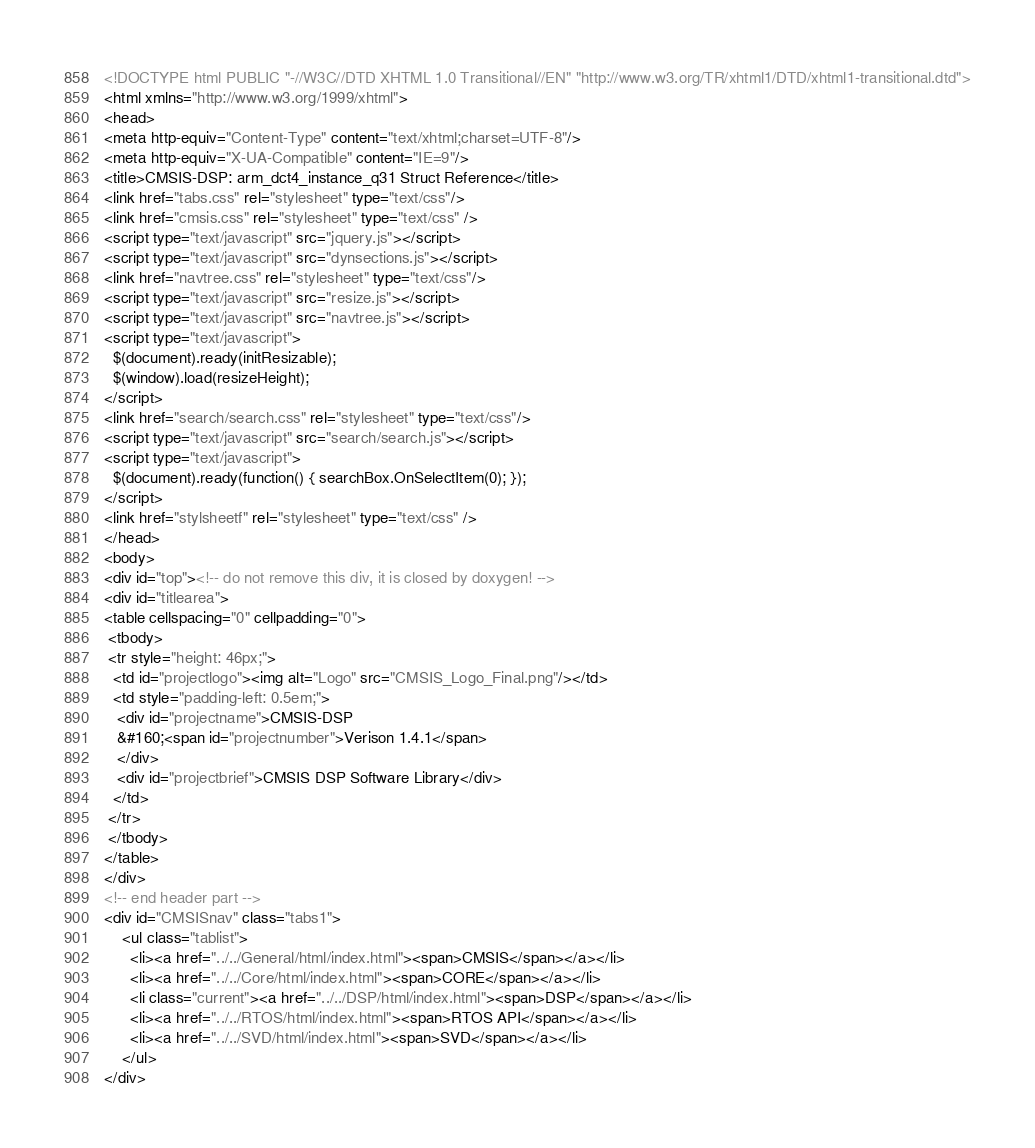Convert code to text. <code><loc_0><loc_0><loc_500><loc_500><_HTML_><!DOCTYPE html PUBLIC "-//W3C//DTD XHTML 1.0 Transitional//EN" "http://www.w3.org/TR/xhtml1/DTD/xhtml1-transitional.dtd">
<html xmlns="http://www.w3.org/1999/xhtml">
<head>
<meta http-equiv="Content-Type" content="text/xhtml;charset=UTF-8"/>
<meta http-equiv="X-UA-Compatible" content="IE=9"/>
<title>CMSIS-DSP: arm_dct4_instance_q31 Struct Reference</title>
<link href="tabs.css" rel="stylesheet" type="text/css"/>
<link href="cmsis.css" rel="stylesheet" type="text/css" />
<script type="text/javascript" src="jquery.js"></script>
<script type="text/javascript" src="dynsections.js"></script>
<link href="navtree.css" rel="stylesheet" type="text/css"/>
<script type="text/javascript" src="resize.js"></script>
<script type="text/javascript" src="navtree.js"></script>
<script type="text/javascript">
  $(document).ready(initResizable);
  $(window).load(resizeHeight);
</script>
<link href="search/search.css" rel="stylesheet" type="text/css"/>
<script type="text/javascript" src="search/search.js"></script>
<script type="text/javascript">
  $(document).ready(function() { searchBox.OnSelectItem(0); });
</script>
<link href="stylsheetf" rel="stylesheet" type="text/css" />
</head>
<body>
<div id="top"><!-- do not remove this div, it is closed by doxygen! -->
<div id="titlearea">
<table cellspacing="0" cellpadding="0">
 <tbody>
 <tr style="height: 46px;">
  <td id="projectlogo"><img alt="Logo" src="CMSIS_Logo_Final.png"/></td>
  <td style="padding-left: 0.5em;">
   <div id="projectname">CMSIS-DSP
   &#160;<span id="projectnumber">Verison 1.4.1</span>
   </div>
   <div id="projectbrief">CMSIS DSP Software Library</div>
  </td>
 </tr>
 </tbody>
</table>
</div>
<!-- end header part -->
<div id="CMSISnav" class="tabs1">
    <ul class="tablist">
      <li><a href="../../General/html/index.html"><span>CMSIS</span></a></li>
      <li><a href="../../Core/html/index.html"><span>CORE</span></a></li>
      <li class="current"><a href="../../DSP/html/index.html"><span>DSP</span></a></li>
      <li><a href="../../RTOS/html/index.html"><span>RTOS API</span></a></li>
      <li><a href="../../SVD/html/index.html"><span>SVD</span></a></li>
    </ul>
</div></code> 